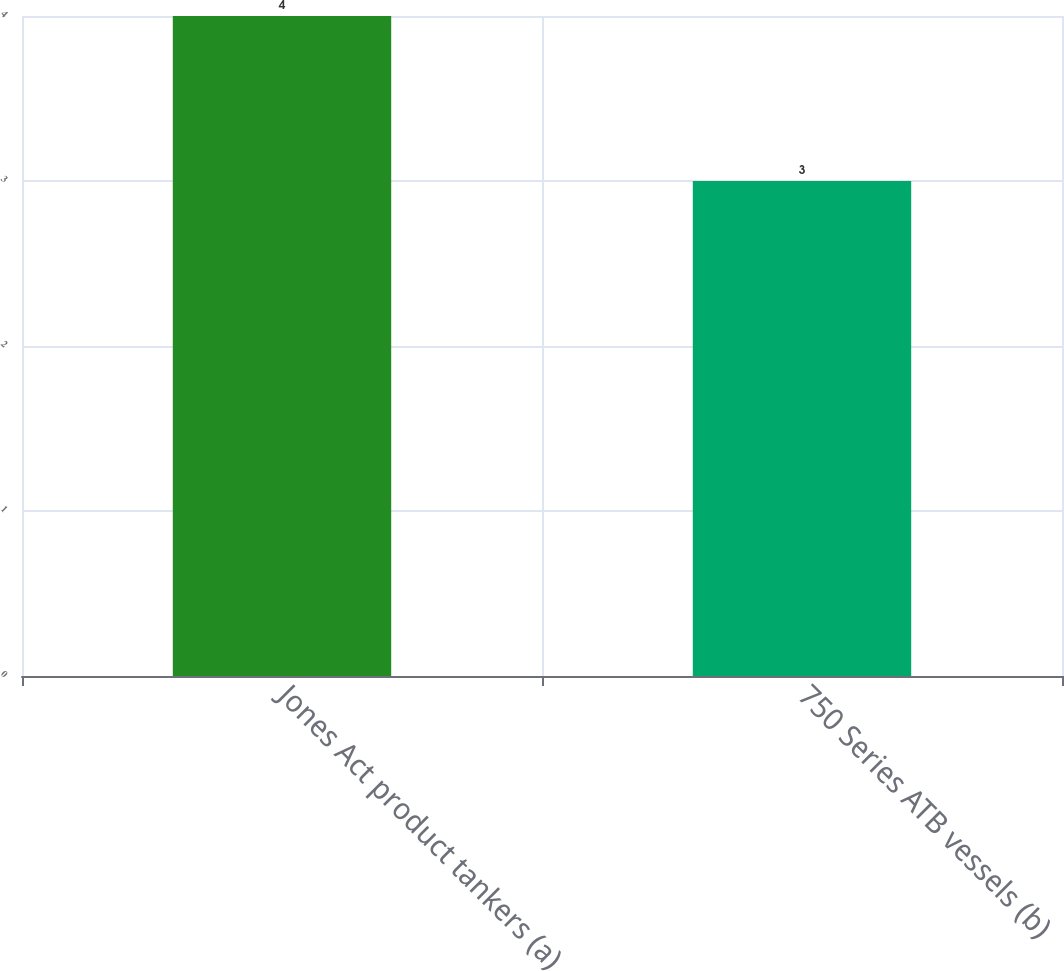<chart> <loc_0><loc_0><loc_500><loc_500><bar_chart><fcel>Jones Act product tankers (a)<fcel>750 Series ATB vessels (b)<nl><fcel>4<fcel>3<nl></chart> 